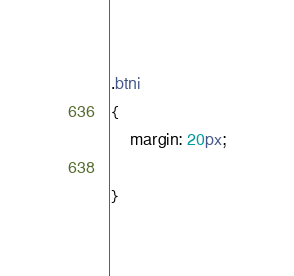Convert code to text. <code><loc_0><loc_0><loc_500><loc_500><_CSS_>.btni
{
    margin: 20px;

}</code> 